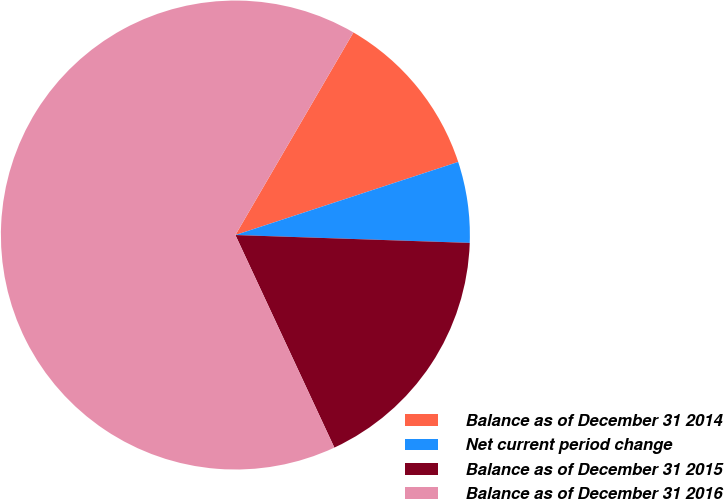Convert chart. <chart><loc_0><loc_0><loc_500><loc_500><pie_chart><fcel>Balance as of December 31 2014<fcel>Net current period change<fcel>Balance as of December 31 2015<fcel>Balance as of December 31 2016<nl><fcel>11.56%<fcel>5.58%<fcel>17.53%<fcel>65.33%<nl></chart> 